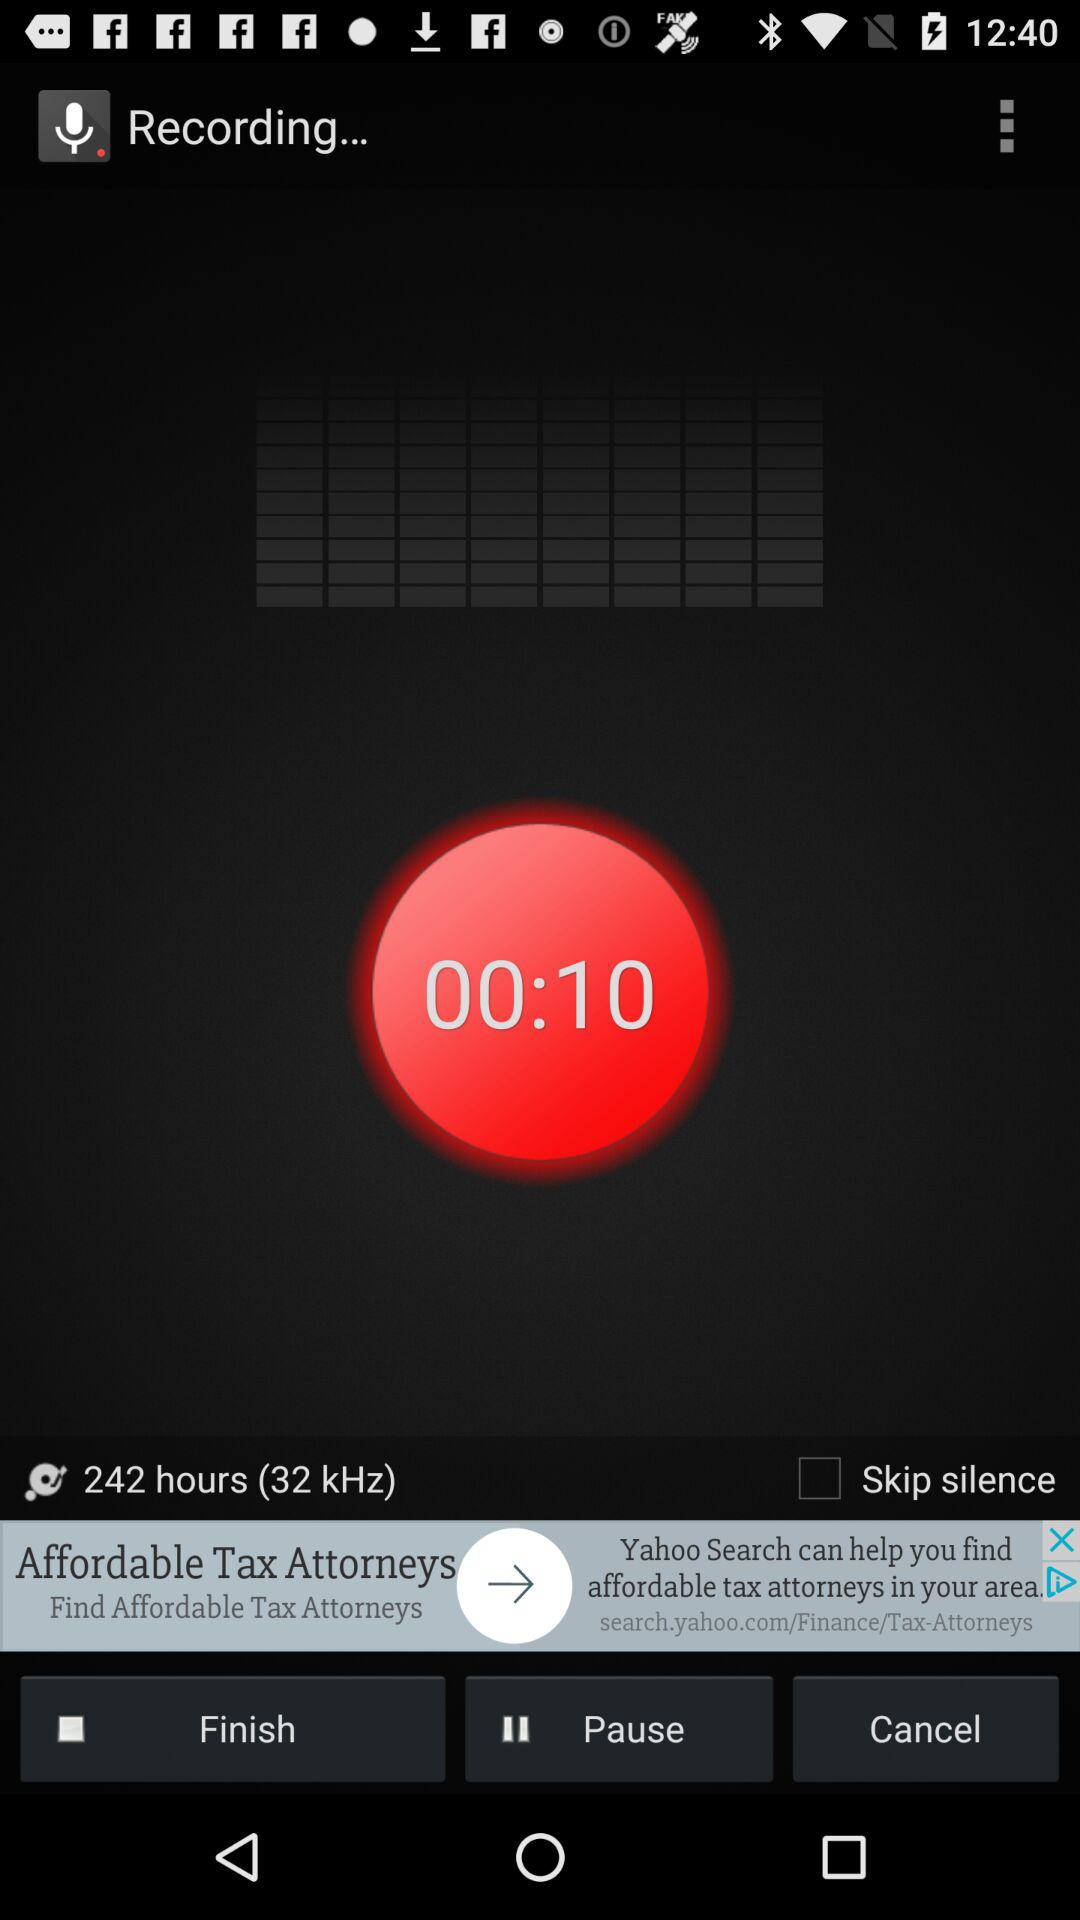What is the status of "Skip silence"? The status is "off". 